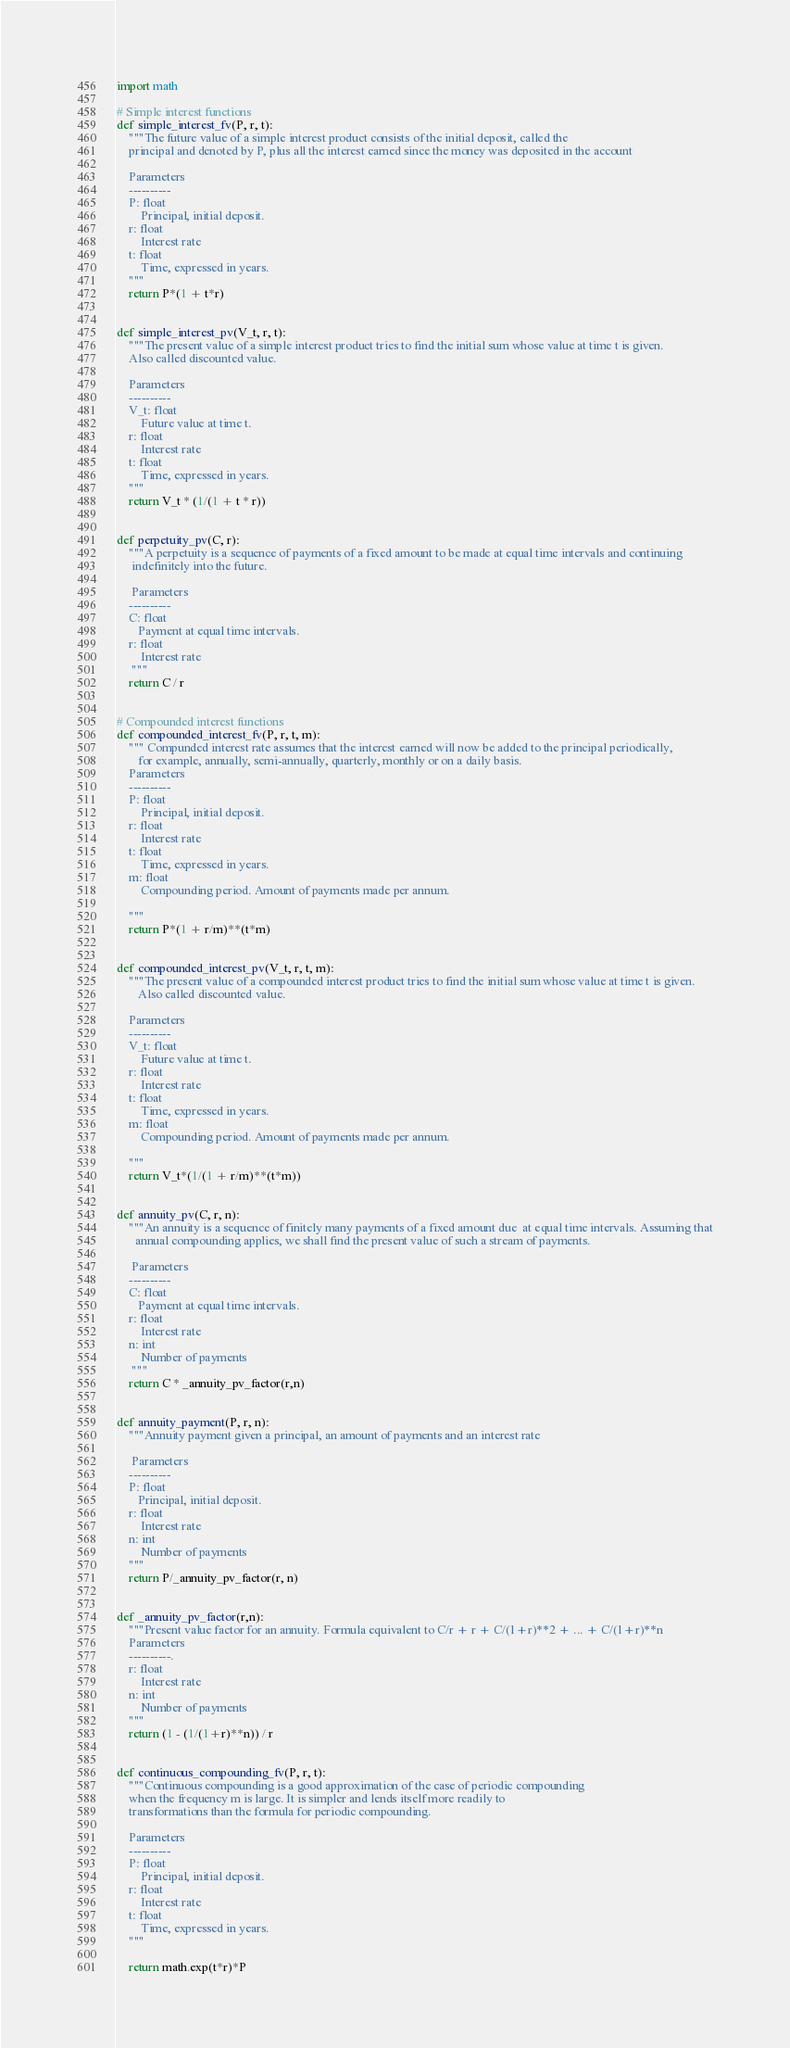Convert code to text. <code><loc_0><loc_0><loc_500><loc_500><_Python_>import math

# Simple interest functions
def simple_interest_fv(P, r, t):
    """The future value of a simple interest product consists of the initial deposit, called the
    principal and denoted by P, plus all the interest earned since the money was deposited in the account

    Parameters
    ----------
    P: float
        Principal, initial deposit.
    r: float
        Interest rate
    t: float
        Time, expressed in years.
    """
    return P*(1 + t*r)


def simple_interest_pv(V_t, r, t):
    """The present value of a simple interest product tries to find the initial sum whose value at time t is given.
    Also called discounted value.

    Parameters
    ----------
    V_t: float
        Future value at time t.
    r: float
        Interest rate
    t: float
        Time, expressed in years.
    """
    return V_t * (1/(1 + t * r))


def perpetuity_pv(C, r):
    """A perpetuity is a sequence of payments of a fixed amount to be made at equal time intervals and continuing
     indefinitely into the future.

     Parameters
    ----------
    C: float
       Payment at equal time intervals.
    r: float
        Interest rate
     """
    return C / r


# Compounded interest functions
def compounded_interest_fv(P, r, t, m):
    """ Compunded interest rate assumes that the interest earned will now be added to the principal periodically,
       for example, annually, semi-annually, quarterly, monthly or on a daily basis.
    Parameters
    ----------
    P: float
        Principal, initial deposit.
    r: float
        Interest rate
    t: float
        Time, expressed in years.
    m: float
        Compounding period. Amount of payments made per annum.

    """
    return P*(1 + r/m)**(t*m)


def compounded_interest_pv(V_t, r, t, m):
    """The present value of a compounded interest product tries to find the initial sum whose value at time t is given.
       Also called discounted value.

    Parameters
    ----------
    V_t: float
        Future value at time t.
    r: float
        Interest rate
    t: float
        Time, expressed in years.
    m: float
        Compounding period. Amount of payments made per annum.

    """
    return V_t*(1/(1 + r/m)**(t*m))


def annuity_pv(C, r, n):
    """An annuity is a sequence of finitely many payments of a fixed amount due  at equal time intervals. Assuming that
      annual compounding applies, we shall find the present value of such a stream of payments.

     Parameters
    ----------
    C: float
       Payment at equal time intervals.
    r: float
        Interest rate
    n: int
        Number of payments
     """
    return C * _annuity_pv_factor(r,n)


def annuity_payment(P, r, n):
    """Annuity payment given a principal, an amount of payments and an interest rate

     Parameters
    ----------
    P: float
       Principal, initial deposit.
    r: float
        Interest rate
    n: int
        Number of payments
    """
    return P/_annuity_pv_factor(r, n)


def _annuity_pv_factor(r,n):
    """Present value factor for an annuity. Formula equivalent to C/r + r + C/(1+r)**2 + ... + C/(1+r)**n
    Parameters
    ----------.
    r: float
        Interest rate
    n: int
        Number of payments
    """
    return (1 - (1/(1+r)**n)) / r


def continuous_compounding_fv(P, r, t):
    """Continuous compounding is a good approximation of the case of periodic compounding
    when the frequency m is large. It is simpler and lends itself more readily to
    transformations than the formula for periodic compounding.

    Parameters
    ----------
    P: float
        Principal, initial deposit.
    r: float
        Interest rate
    t: float
        Time, expressed in years.
    """

    return math.exp(t*r)*P

</code> 